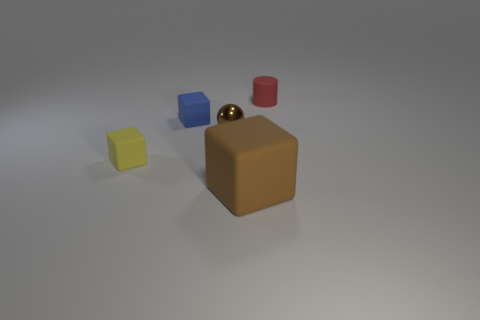Can you tell me more about the arrangement of these objects? Certainly! We're looking at four objects neatly placed with space between them on a neutral background. From left to right, there's a yellow cube, a blue cylinder, a brown metallic sphere, and a red cylinder. The arrangement suggests an intentional display possibly for a comparative study of geometric shapes, colors, and materials. 